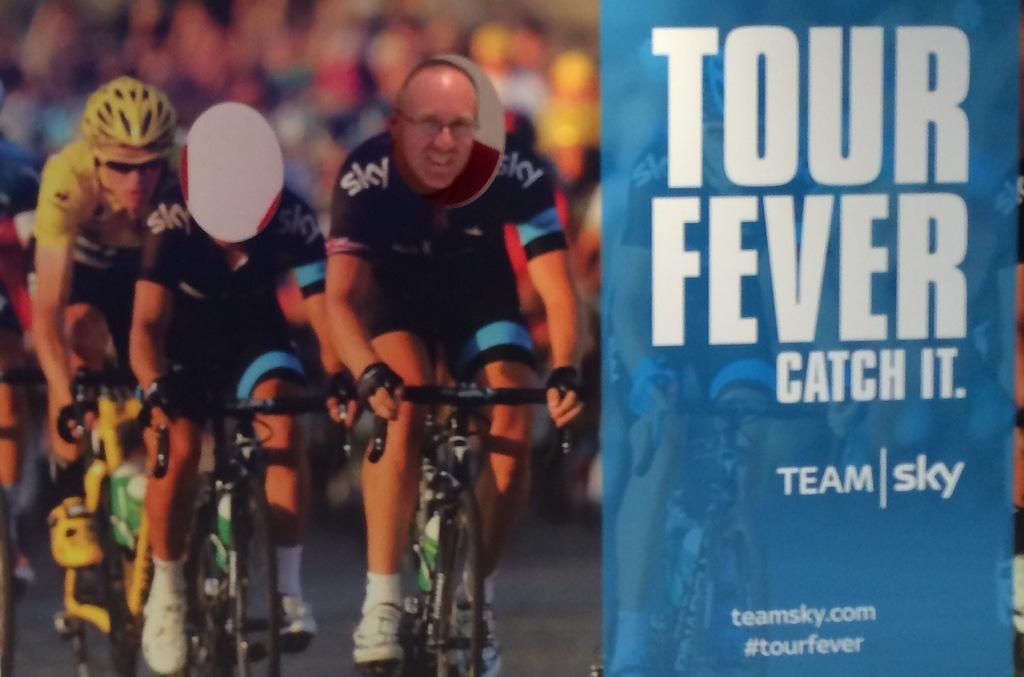Who or what is present in the image? There is a person in the image. What type of objects can be seen in the image? There are cycles in the image. Are there any words or symbols in the image? Yes, there is text in the image. What type of art can be seen on the ground in the image? There is no art or ground visible in the image; it only features a person, cycles, and text. 